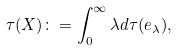Convert formula to latex. <formula><loc_0><loc_0><loc_500><loc_500>\tau ( X ) \colon = \int _ { 0 } ^ { \infty } \lambda d \tau ( e _ { \lambda } ) ,</formula> 